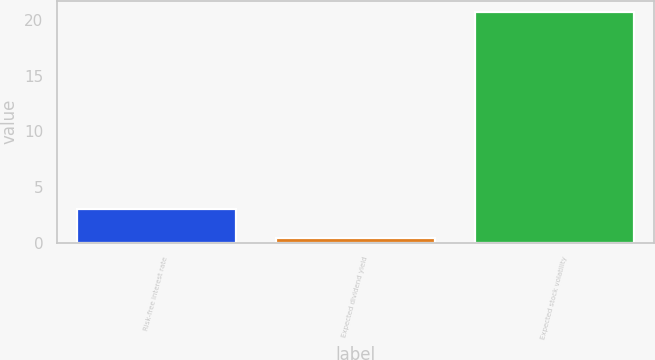Convert chart. <chart><loc_0><loc_0><loc_500><loc_500><bar_chart><fcel>Risk-free interest rate<fcel>Expected dividend yield<fcel>Expected stock volatility<nl><fcel>3<fcel>0.4<fcel>20.7<nl></chart> 